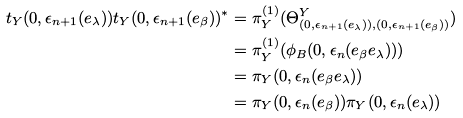Convert formula to latex. <formula><loc_0><loc_0><loc_500><loc_500>t _ { Y } ( 0 , \epsilon _ { n + 1 } ( e _ { \lambda } ) ) t _ { Y } ( 0 , \epsilon _ { n + 1 } ( e _ { \beta } ) ) ^ { * } & = \pi _ { Y } ^ { ( 1 ) } ( \Theta _ { ( 0 , \epsilon _ { n + 1 } ( e _ { \lambda } ) ) , ( 0 , \epsilon _ { n + 1 } ( e _ { \beta } ) ) } ^ { Y } ) \\ & = \pi _ { Y } ^ { ( 1 ) } ( \phi _ { B } ( 0 , \epsilon _ { n } ( e _ { \beta } e _ { \lambda } ) ) ) \\ & = \pi _ { Y } ( 0 , \epsilon _ { n } ( e _ { \beta } e _ { \lambda } ) ) \\ & = \pi _ { Y } ( 0 , \epsilon _ { n } ( e _ { \beta } ) ) \pi _ { Y } ( 0 , \epsilon _ { n } ( e _ { \lambda } ) )</formula> 